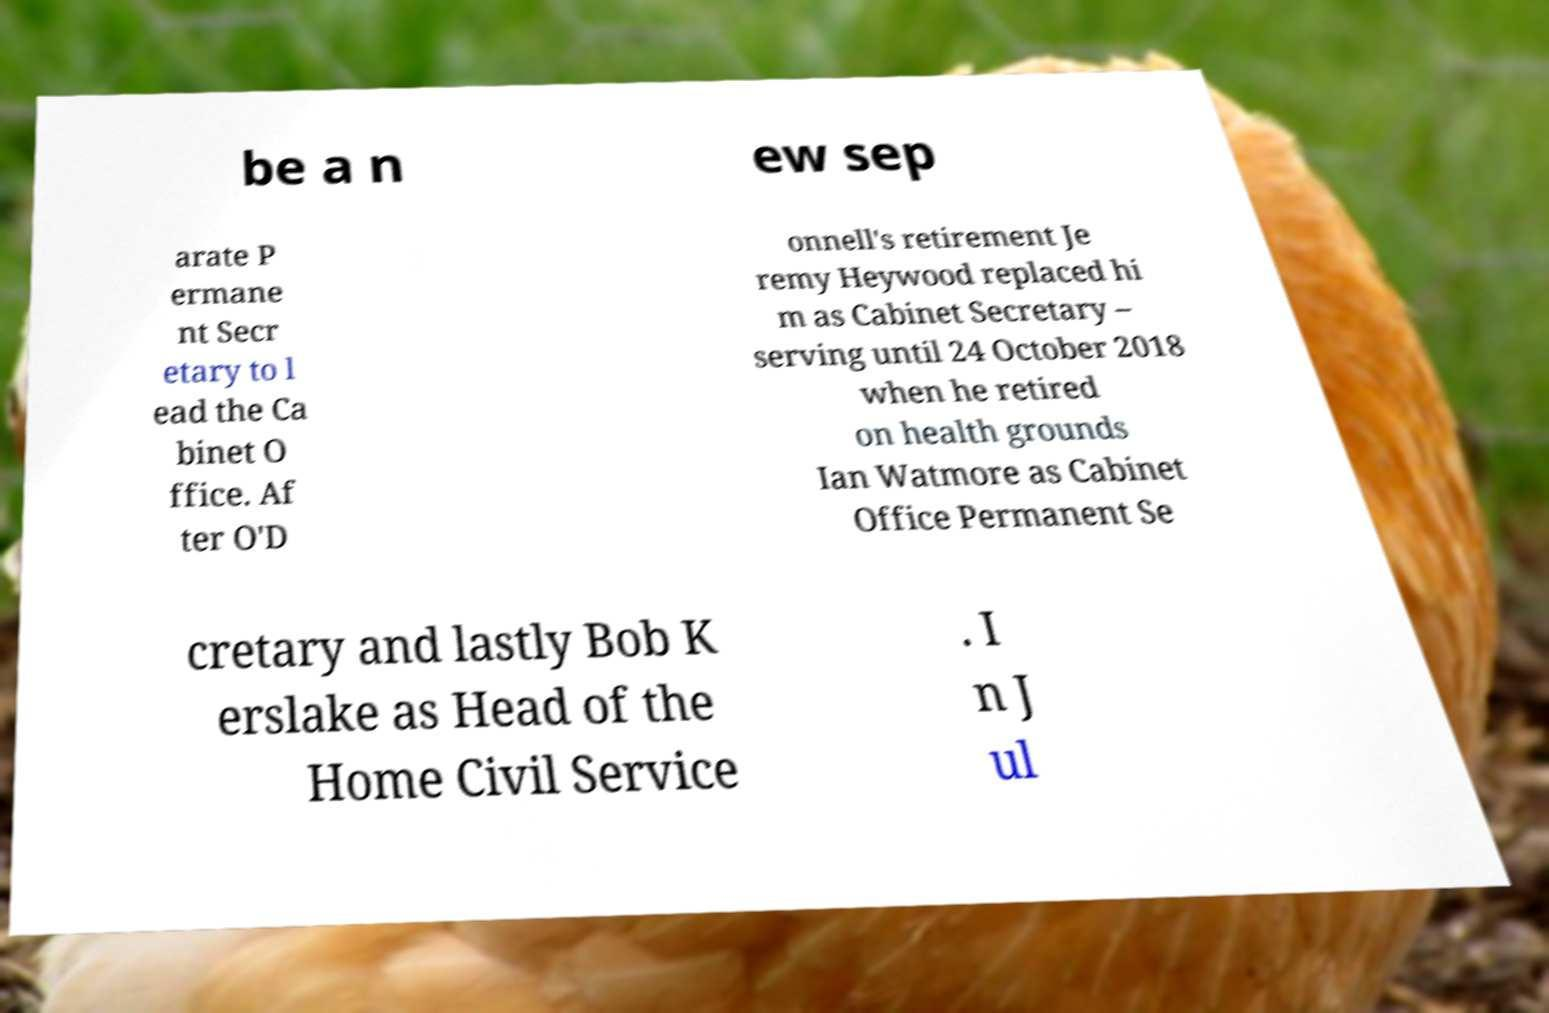Please read and relay the text visible in this image. What does it say? be a n ew sep arate P ermane nt Secr etary to l ead the Ca binet O ffice. Af ter O'D onnell's retirement Je remy Heywood replaced hi m as Cabinet Secretary – serving until 24 October 2018 when he retired on health grounds Ian Watmore as Cabinet Office Permanent Se cretary and lastly Bob K erslake as Head of the Home Civil Service . I n J ul 